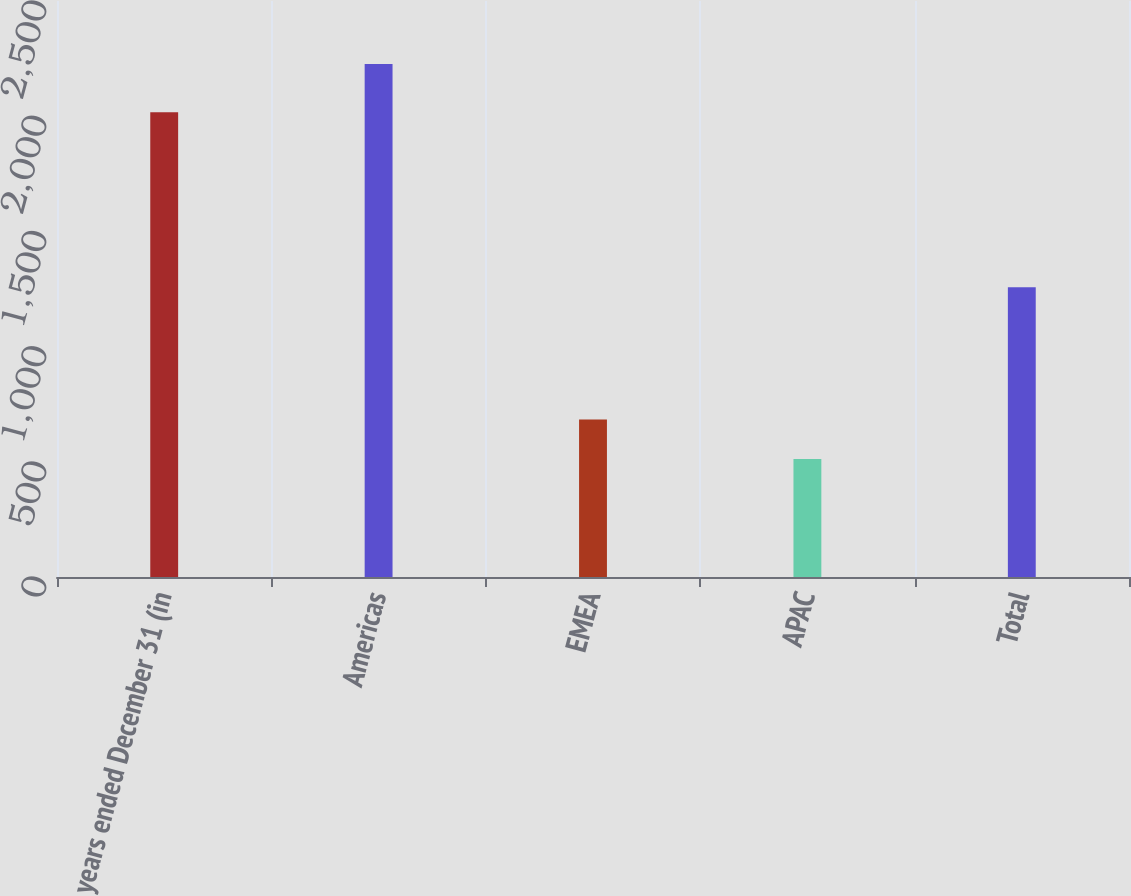Convert chart. <chart><loc_0><loc_0><loc_500><loc_500><bar_chart><fcel>years ended December 31 (in<fcel>Americas<fcel>EMEA<fcel>APAC<fcel>Total<nl><fcel>2017<fcel>2227<fcel>683.5<fcel>512<fcel>1258<nl></chart> 